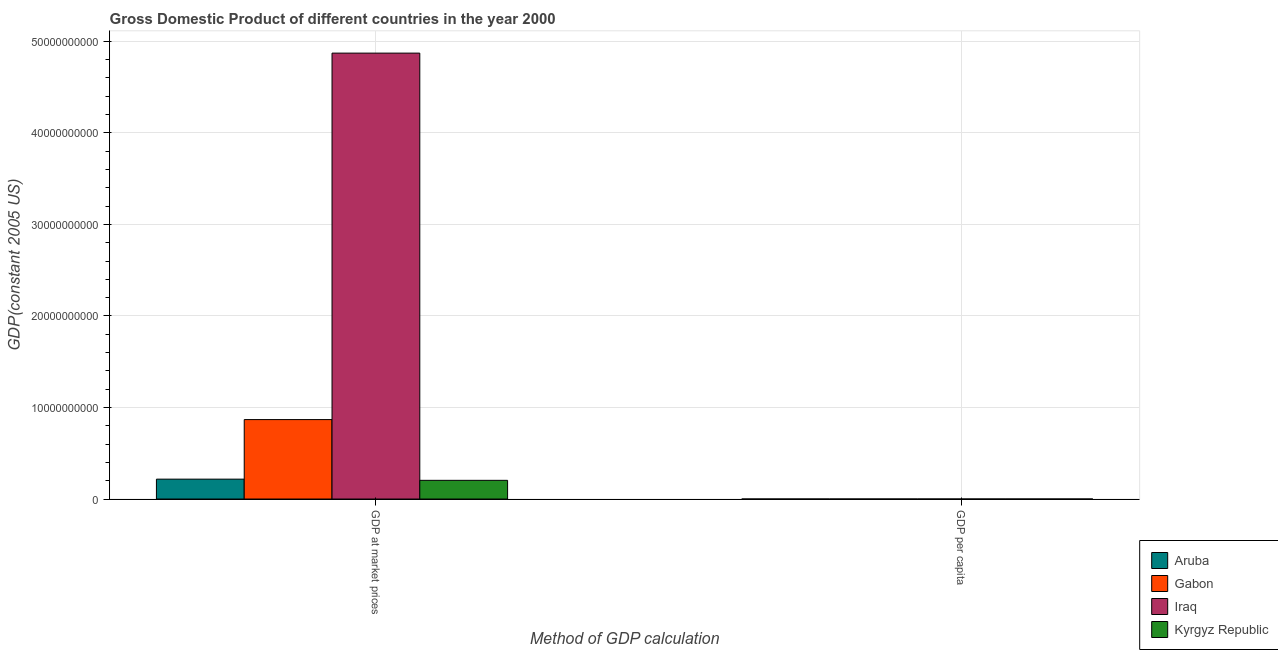How many different coloured bars are there?
Offer a very short reply. 4. Are the number of bars on each tick of the X-axis equal?
Your response must be concise. Yes. How many bars are there on the 2nd tick from the right?
Provide a short and direct response. 4. What is the label of the 2nd group of bars from the left?
Your answer should be very brief. GDP per capita. What is the gdp per capita in Kyrgyz Republic?
Keep it short and to the point. 417.11. Across all countries, what is the maximum gdp per capita?
Provide a succinct answer. 2.39e+04. Across all countries, what is the minimum gdp per capita?
Your answer should be compact. 417.11. In which country was the gdp per capita maximum?
Ensure brevity in your answer.  Aruba. In which country was the gdp at market prices minimum?
Your answer should be very brief. Kyrgyz Republic. What is the total gdp at market prices in the graph?
Provide a succinct answer. 6.16e+1. What is the difference between the gdp per capita in Kyrgyz Republic and that in Aruba?
Ensure brevity in your answer.  -2.35e+04. What is the difference between the gdp per capita in Iraq and the gdp at market prices in Aruba?
Your response must be concise. -2.17e+09. What is the average gdp at market prices per country?
Provide a short and direct response. 1.54e+1. What is the difference between the gdp per capita and gdp at market prices in Kyrgyz Republic?
Ensure brevity in your answer.  -2.04e+09. What is the ratio of the gdp per capita in Iraq to that in Aruba?
Offer a terse response. 0.09. In how many countries, is the gdp at market prices greater than the average gdp at market prices taken over all countries?
Give a very brief answer. 1. What does the 3rd bar from the left in GDP at market prices represents?
Make the answer very short. Iraq. What does the 1st bar from the right in GDP per capita represents?
Make the answer very short. Kyrgyz Republic. Are the values on the major ticks of Y-axis written in scientific E-notation?
Offer a terse response. No. Does the graph contain grids?
Ensure brevity in your answer.  Yes. How are the legend labels stacked?
Your response must be concise. Vertical. What is the title of the graph?
Your answer should be compact. Gross Domestic Product of different countries in the year 2000. What is the label or title of the X-axis?
Offer a terse response. Method of GDP calculation. What is the label or title of the Y-axis?
Keep it short and to the point. GDP(constant 2005 US). What is the GDP(constant 2005 US) of Aruba in GDP at market prices?
Your answer should be very brief. 2.17e+09. What is the GDP(constant 2005 US) in Gabon in GDP at market prices?
Your answer should be compact. 8.68e+09. What is the GDP(constant 2005 US) of Iraq in GDP at market prices?
Provide a short and direct response. 4.87e+1. What is the GDP(constant 2005 US) in Kyrgyz Republic in GDP at market prices?
Keep it short and to the point. 2.04e+09. What is the GDP(constant 2005 US) of Aruba in GDP per capita?
Offer a terse response. 2.39e+04. What is the GDP(constant 2005 US) in Gabon in GDP per capita?
Make the answer very short. 7047.6. What is the GDP(constant 2005 US) of Iraq in GDP per capita?
Make the answer very short. 2066.31. What is the GDP(constant 2005 US) in Kyrgyz Republic in GDP per capita?
Provide a succinct answer. 417.11. Across all Method of GDP calculation, what is the maximum GDP(constant 2005 US) in Aruba?
Your answer should be very brief. 2.17e+09. Across all Method of GDP calculation, what is the maximum GDP(constant 2005 US) in Gabon?
Your answer should be very brief. 8.68e+09. Across all Method of GDP calculation, what is the maximum GDP(constant 2005 US) of Iraq?
Your response must be concise. 4.87e+1. Across all Method of GDP calculation, what is the maximum GDP(constant 2005 US) in Kyrgyz Republic?
Your answer should be very brief. 2.04e+09. Across all Method of GDP calculation, what is the minimum GDP(constant 2005 US) of Aruba?
Provide a short and direct response. 2.39e+04. Across all Method of GDP calculation, what is the minimum GDP(constant 2005 US) of Gabon?
Your answer should be compact. 7047.6. Across all Method of GDP calculation, what is the minimum GDP(constant 2005 US) of Iraq?
Make the answer very short. 2066.31. Across all Method of GDP calculation, what is the minimum GDP(constant 2005 US) in Kyrgyz Republic?
Your answer should be very brief. 417.11. What is the total GDP(constant 2005 US) of Aruba in the graph?
Your answer should be compact. 2.17e+09. What is the total GDP(constant 2005 US) in Gabon in the graph?
Ensure brevity in your answer.  8.68e+09. What is the total GDP(constant 2005 US) in Iraq in the graph?
Your answer should be very brief. 4.87e+1. What is the total GDP(constant 2005 US) of Kyrgyz Republic in the graph?
Ensure brevity in your answer.  2.04e+09. What is the difference between the GDP(constant 2005 US) in Aruba in GDP at market prices and that in GDP per capita?
Keep it short and to the point. 2.17e+09. What is the difference between the GDP(constant 2005 US) in Gabon in GDP at market prices and that in GDP per capita?
Your answer should be compact. 8.68e+09. What is the difference between the GDP(constant 2005 US) of Iraq in GDP at market prices and that in GDP per capita?
Keep it short and to the point. 4.87e+1. What is the difference between the GDP(constant 2005 US) of Kyrgyz Republic in GDP at market prices and that in GDP per capita?
Offer a terse response. 2.04e+09. What is the difference between the GDP(constant 2005 US) of Aruba in GDP at market prices and the GDP(constant 2005 US) of Gabon in GDP per capita?
Your response must be concise. 2.17e+09. What is the difference between the GDP(constant 2005 US) of Aruba in GDP at market prices and the GDP(constant 2005 US) of Iraq in GDP per capita?
Offer a very short reply. 2.17e+09. What is the difference between the GDP(constant 2005 US) of Aruba in GDP at market prices and the GDP(constant 2005 US) of Kyrgyz Republic in GDP per capita?
Your answer should be compact. 2.17e+09. What is the difference between the GDP(constant 2005 US) of Gabon in GDP at market prices and the GDP(constant 2005 US) of Iraq in GDP per capita?
Your answer should be compact. 8.68e+09. What is the difference between the GDP(constant 2005 US) of Gabon in GDP at market prices and the GDP(constant 2005 US) of Kyrgyz Republic in GDP per capita?
Ensure brevity in your answer.  8.68e+09. What is the difference between the GDP(constant 2005 US) in Iraq in GDP at market prices and the GDP(constant 2005 US) in Kyrgyz Republic in GDP per capita?
Your answer should be compact. 4.87e+1. What is the average GDP(constant 2005 US) of Aruba per Method of GDP calculation?
Your answer should be very brief. 1.09e+09. What is the average GDP(constant 2005 US) of Gabon per Method of GDP calculation?
Give a very brief answer. 4.34e+09. What is the average GDP(constant 2005 US) in Iraq per Method of GDP calculation?
Your answer should be very brief. 2.44e+1. What is the average GDP(constant 2005 US) of Kyrgyz Republic per Method of GDP calculation?
Keep it short and to the point. 1.02e+09. What is the difference between the GDP(constant 2005 US) in Aruba and GDP(constant 2005 US) in Gabon in GDP at market prices?
Offer a very short reply. -6.51e+09. What is the difference between the GDP(constant 2005 US) in Aruba and GDP(constant 2005 US) in Iraq in GDP at market prices?
Give a very brief answer. -4.65e+1. What is the difference between the GDP(constant 2005 US) of Aruba and GDP(constant 2005 US) of Kyrgyz Republic in GDP at market prices?
Make the answer very short. 1.29e+08. What is the difference between the GDP(constant 2005 US) of Gabon and GDP(constant 2005 US) of Iraq in GDP at market prices?
Your answer should be compact. -4.00e+1. What is the difference between the GDP(constant 2005 US) of Gabon and GDP(constant 2005 US) of Kyrgyz Republic in GDP at market prices?
Offer a very short reply. 6.64e+09. What is the difference between the GDP(constant 2005 US) of Iraq and GDP(constant 2005 US) of Kyrgyz Republic in GDP at market prices?
Make the answer very short. 4.67e+1. What is the difference between the GDP(constant 2005 US) in Aruba and GDP(constant 2005 US) in Gabon in GDP per capita?
Make the answer very short. 1.69e+04. What is the difference between the GDP(constant 2005 US) of Aruba and GDP(constant 2005 US) of Iraq in GDP per capita?
Make the answer very short. 2.18e+04. What is the difference between the GDP(constant 2005 US) in Aruba and GDP(constant 2005 US) in Kyrgyz Republic in GDP per capita?
Provide a short and direct response. 2.35e+04. What is the difference between the GDP(constant 2005 US) in Gabon and GDP(constant 2005 US) in Iraq in GDP per capita?
Provide a short and direct response. 4981.29. What is the difference between the GDP(constant 2005 US) of Gabon and GDP(constant 2005 US) of Kyrgyz Republic in GDP per capita?
Ensure brevity in your answer.  6630.49. What is the difference between the GDP(constant 2005 US) in Iraq and GDP(constant 2005 US) in Kyrgyz Republic in GDP per capita?
Offer a terse response. 1649.2. What is the ratio of the GDP(constant 2005 US) in Aruba in GDP at market prices to that in GDP per capita?
Ensure brevity in your answer.  9.09e+04. What is the ratio of the GDP(constant 2005 US) in Gabon in GDP at market prices to that in GDP per capita?
Keep it short and to the point. 1.23e+06. What is the ratio of the GDP(constant 2005 US) in Iraq in GDP at market prices to that in GDP per capita?
Provide a succinct answer. 2.36e+07. What is the ratio of the GDP(constant 2005 US) of Kyrgyz Republic in GDP at market prices to that in GDP per capita?
Keep it short and to the point. 4.90e+06. What is the difference between the highest and the second highest GDP(constant 2005 US) in Aruba?
Keep it short and to the point. 2.17e+09. What is the difference between the highest and the second highest GDP(constant 2005 US) in Gabon?
Keep it short and to the point. 8.68e+09. What is the difference between the highest and the second highest GDP(constant 2005 US) in Iraq?
Your answer should be very brief. 4.87e+1. What is the difference between the highest and the second highest GDP(constant 2005 US) in Kyrgyz Republic?
Make the answer very short. 2.04e+09. What is the difference between the highest and the lowest GDP(constant 2005 US) in Aruba?
Provide a short and direct response. 2.17e+09. What is the difference between the highest and the lowest GDP(constant 2005 US) of Gabon?
Offer a very short reply. 8.68e+09. What is the difference between the highest and the lowest GDP(constant 2005 US) of Iraq?
Keep it short and to the point. 4.87e+1. What is the difference between the highest and the lowest GDP(constant 2005 US) of Kyrgyz Republic?
Give a very brief answer. 2.04e+09. 